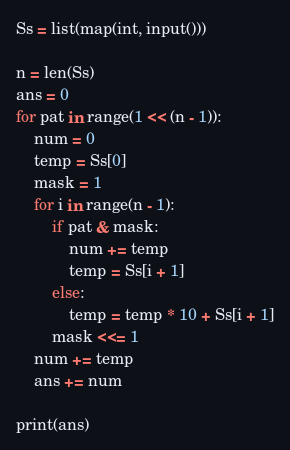<code> <loc_0><loc_0><loc_500><loc_500><_Python_>Ss = list(map(int, input()))

n = len(Ss)
ans = 0
for pat in range(1 << (n - 1)):
    num = 0
    temp = Ss[0]
    mask = 1
    for i in range(n - 1):
        if pat & mask:
            num += temp
            temp = Ss[i + 1]
        else:
            temp = temp * 10 + Ss[i + 1]
        mask <<= 1
    num += temp
    ans += num

print(ans)
</code> 